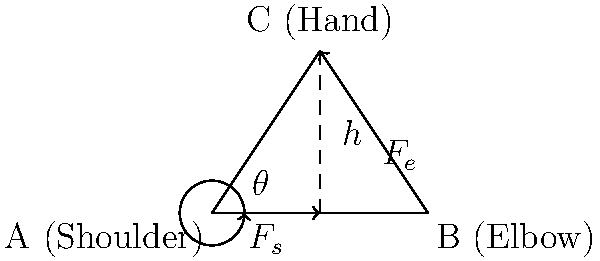In archery, optimal body positioning is crucial for maximizing draw strength. Consider the simplified model of an archer's upper body shown in the diagram, where A represents the shoulder, B the elbow, and C the hand holding the bowstring. The shoulder force is denoted as $F_s$, and the elbow force as $F_e$. If the archer aims to maximize the horizontal component of the draw force, what is the optimal angle $\theta$ between the upper arm (AB) and the vertical axis? To determine the optimal angle for maximizing the horizontal component of the draw force, we need to follow these steps:

1) The total horizontal force is the sum of the horizontal components of $F_s$ and $F_e$.

2) The horizontal component of $F_s$ is $F_s \cos\theta$.

3) For $F_e$, we need to consider the angle it makes with the horizontal. Let's call this angle $\phi$. The horizontal component of $F_e$ is $F_e \cos\phi$.

4) The total horizontal force is thus: $F_H = F_s \cos\theta + F_e \cos\phi$.

5) We need to express $\phi$ in terms of $\theta$. From the triangle ABC:
   $\tan\phi = \frac{h}{AB - AB\cos\theta} = \frac{h}{AB(1-\cos\theta)}$

6) Using the identity $\cos\phi = \frac{1}{\sqrt{1+\tan^2\phi}}$, we can express $\cos\phi$ in terms of $\theta$.

7) Now, $F_H$ is a function of $\theta$ only. To find the maximum, we need to differentiate $F_H$ with respect to $\theta$ and set it to zero.

8) After differentiation and simplification, we get the condition:
   $F_s \sin\theta = F_e \sin\phi$

9) This condition is satisfied when the forces $F_s$ and $F_e$ are perpendicular to each other.

10) In a right-angled triangle, this occurs when the two non-right angles are complementary, i.e., they sum to 90°.

11) Therefore, the optimal angle $\theta$ is 45°, as this makes $\phi$ also 45°, satisfying the perpendicularity condition.
Answer: 45° 